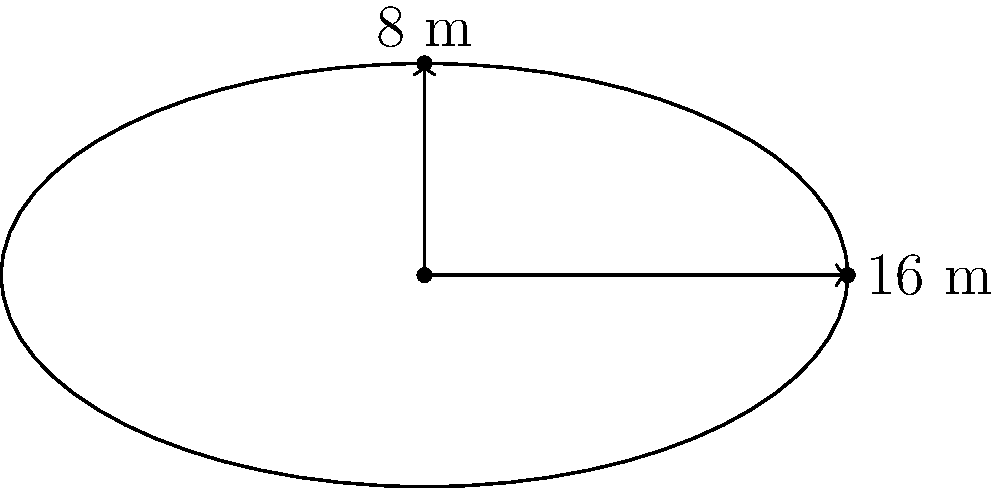You're designing a new oval-shaped swimming pool for your training facility. The pool measures 16 meters in length and 8 meters in width at its widest points. What is the approximate area of the pool in square meters? Use $\pi \approx 3.14$ for your calculations. To find the area of an oval-shaped pool, we can use the formula for the area of an ellipse:

$$A = \pi ab$$

Where:
$A$ = area
$a$ = half of the length (semi-major axis)
$b$ = half of the width (semi-minor axis)

Step 1: Determine the values of $a$ and $b$
$a = 16 \div 2 = 8$ meters
$b = 8 \div 2 = 4$ meters

Step 2: Substitute the values into the formula
$$A = \pi ab$$
$$A = 3.14 \times 8 \times 4$$

Step 3: Calculate the result
$$A = 3.14 \times 32 = 100.48$$

Therefore, the approximate area of the oval-shaped swimming pool is 100.48 square meters.
Answer: 100.48 m² 